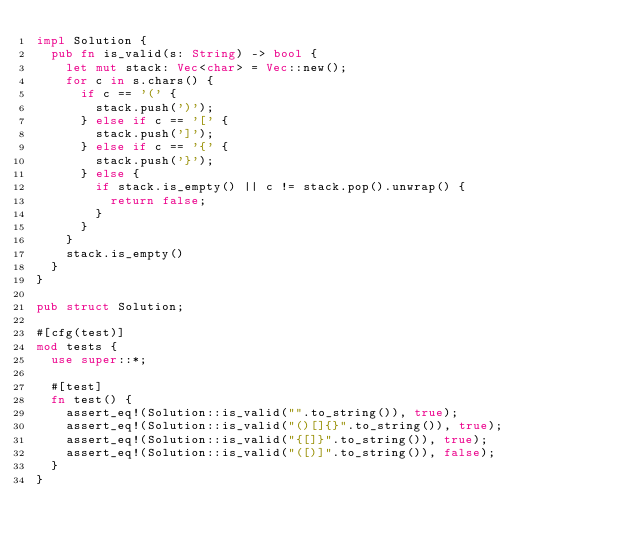<code> <loc_0><loc_0><loc_500><loc_500><_Rust_>impl Solution {
  pub fn is_valid(s: String) -> bool {
    let mut stack: Vec<char> = Vec::new();
    for c in s.chars() {
      if c == '(' {
        stack.push(')');
      } else if c == '[' {
        stack.push(']');
      } else if c == '{' {
        stack.push('}');
      } else {
        if stack.is_empty() || c != stack.pop().unwrap() {
          return false;
        }
      }
    }
    stack.is_empty()
  }
}

pub struct Solution;

#[cfg(test)]
mod tests {
  use super::*;

  #[test]
  fn test() {
    assert_eq!(Solution::is_valid("".to_string()), true);
    assert_eq!(Solution::is_valid("()[]{}".to_string()), true);
    assert_eq!(Solution::is_valid("{[]}".to_string()), true);
    assert_eq!(Solution::is_valid("([)]".to_string()), false);
  }
}
</code> 